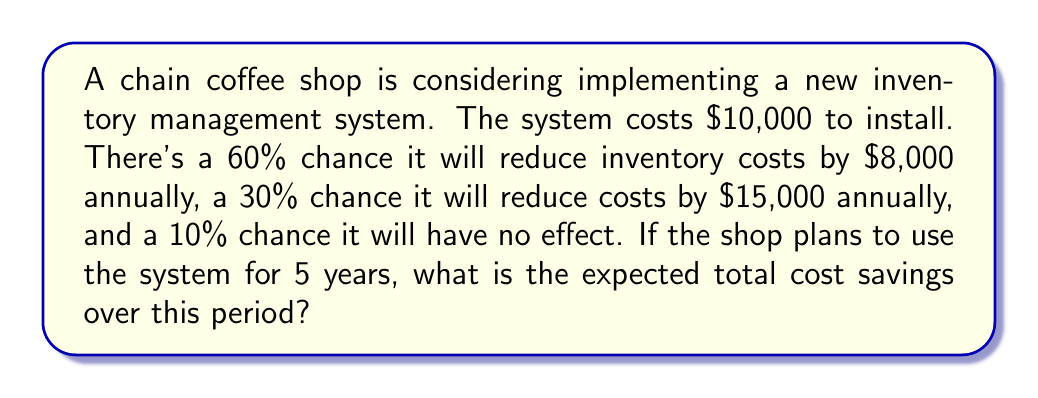Can you answer this question? Let's approach this step-by-step:

1) First, we need to calculate the expected annual savings:

   $$E(\text{annual savings}) = 0.60 \cdot \$8,000 + 0.30 \cdot \$15,000 + 0.10 \cdot \$0$$
   $$= \$4,800 + \$4,500 + \$0 = \$9,300$$

2) Over 5 years, the expected total savings would be:

   $$E(\text{5-year savings}) = 5 \cdot \$9,300 = \$46,500$$

3) However, we need to subtract the cost of the system:

   $$E(\text{total savings}) = \$46,500 - \$10,000 = \$36,500$$

Therefore, the expected total cost savings over 5 years is $36,500.
Answer: $36,500 